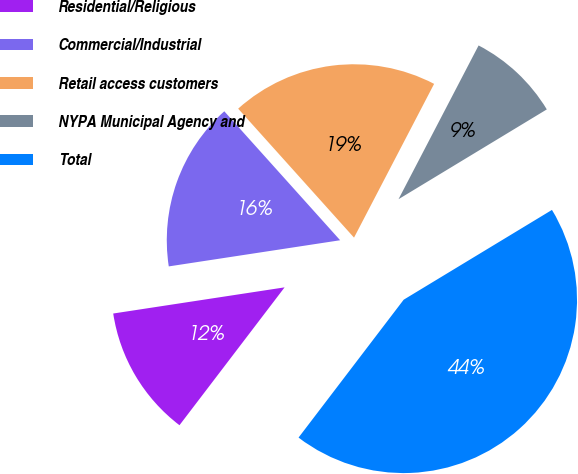<chart> <loc_0><loc_0><loc_500><loc_500><pie_chart><fcel>Residential/Religious<fcel>Commercial/Industrial<fcel>Retail access customers<fcel>NYPA Municipal Agency and<fcel>Total<nl><fcel>12.22%<fcel>15.76%<fcel>19.29%<fcel>8.69%<fcel>44.03%<nl></chart> 